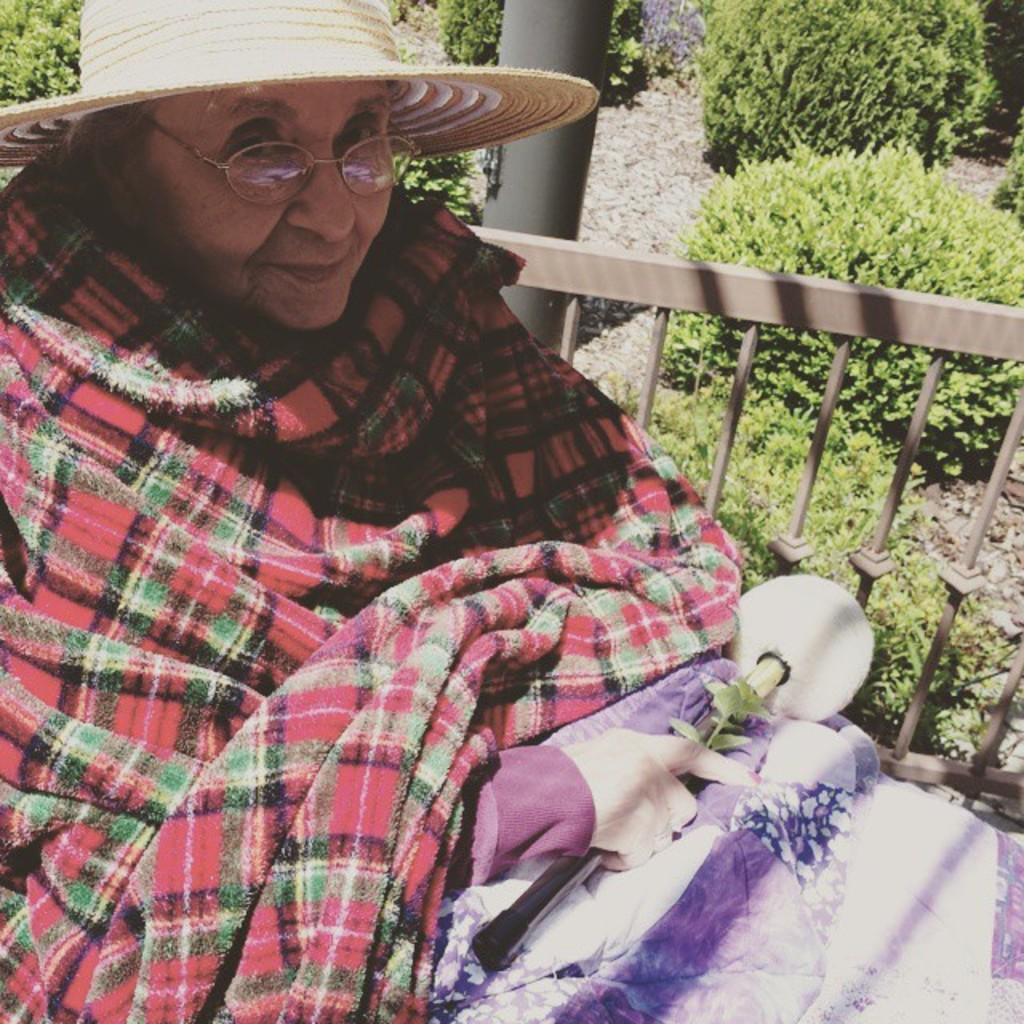Who is present in the image? There is a woman in the image. What is the woman wearing on her head? The woman is wearing a cap. What is the woman holding in the image? The woman is holding an object. What type of structure can be seen in the image? There is a fence visible in the image. Can you describe another object in the image? There is a pole in the image. What type of vegetation is present in the image? There are plants in the image. What type of paste is being used to stick the kite to the basin in the image? There is no kite or basin present in the image, so there is no paste being used. 